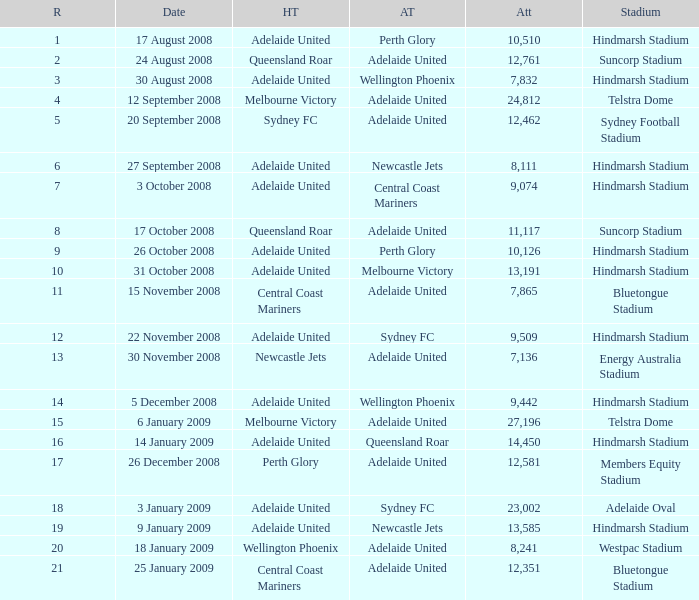What is the round when 11,117 people attended the game on 26 October 2008? 9.0. 